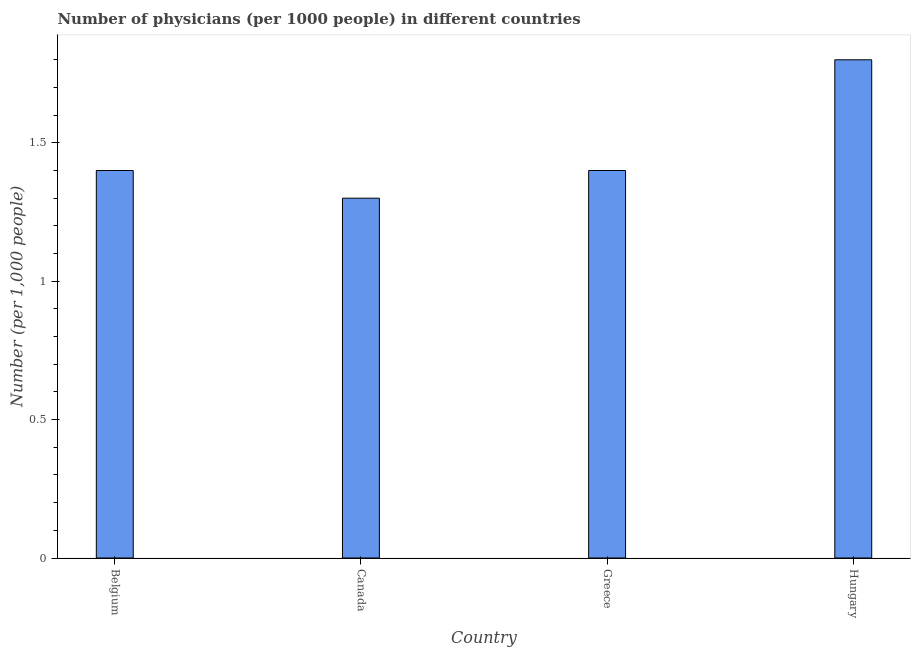Does the graph contain any zero values?
Your response must be concise. No. Does the graph contain grids?
Ensure brevity in your answer.  No. What is the title of the graph?
Your answer should be compact. Number of physicians (per 1000 people) in different countries. What is the label or title of the X-axis?
Provide a succinct answer. Country. What is the label or title of the Y-axis?
Offer a very short reply. Number (per 1,0 people). Across all countries, what is the minimum number of physicians?
Give a very brief answer. 1.3. In which country was the number of physicians maximum?
Offer a terse response. Hungary. What is the sum of the number of physicians?
Offer a very short reply. 5.9. What is the average number of physicians per country?
Offer a terse response. 1.48. In how many countries, is the number of physicians greater than 0.3 ?
Your answer should be very brief. 4. Is the number of physicians in Belgium less than that in Greece?
Your response must be concise. No. What is the difference between the highest and the second highest number of physicians?
Offer a terse response. 0.4. Is the sum of the number of physicians in Canada and Greece greater than the maximum number of physicians across all countries?
Provide a succinct answer. Yes. What is the difference between the highest and the lowest number of physicians?
Keep it short and to the point. 0.5. In how many countries, is the number of physicians greater than the average number of physicians taken over all countries?
Offer a very short reply. 1. How many countries are there in the graph?
Offer a terse response. 4. Are the values on the major ticks of Y-axis written in scientific E-notation?
Provide a succinct answer. No. What is the difference between the Number (per 1,000 people) in Belgium and Canada?
Ensure brevity in your answer.  0.1. What is the difference between the Number (per 1,000 people) in Canada and Greece?
Give a very brief answer. -0.1. What is the difference between the Number (per 1,000 people) in Canada and Hungary?
Keep it short and to the point. -0.5. What is the difference between the Number (per 1,000 people) in Greece and Hungary?
Provide a short and direct response. -0.4. What is the ratio of the Number (per 1,000 people) in Belgium to that in Canada?
Provide a succinct answer. 1.08. What is the ratio of the Number (per 1,000 people) in Belgium to that in Greece?
Your answer should be compact. 1. What is the ratio of the Number (per 1,000 people) in Belgium to that in Hungary?
Your answer should be compact. 0.78. What is the ratio of the Number (per 1,000 people) in Canada to that in Greece?
Provide a succinct answer. 0.93. What is the ratio of the Number (per 1,000 people) in Canada to that in Hungary?
Make the answer very short. 0.72. What is the ratio of the Number (per 1,000 people) in Greece to that in Hungary?
Provide a succinct answer. 0.78. 